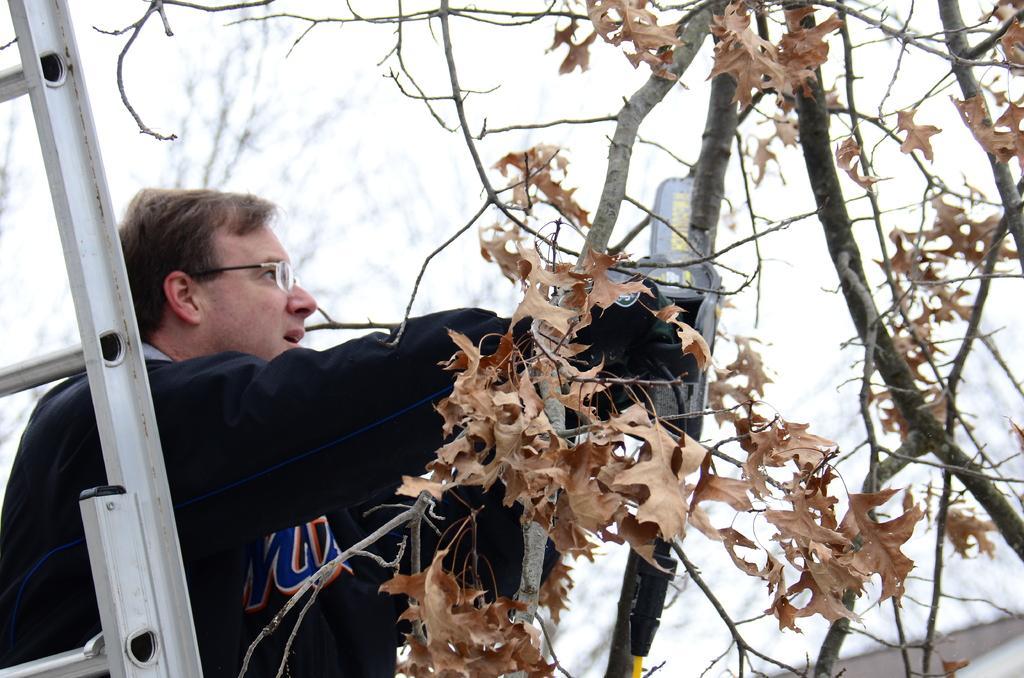In one or two sentences, can you explain what this image depicts? In this image there is a man standing in front of ladder holding something beside the tree. 